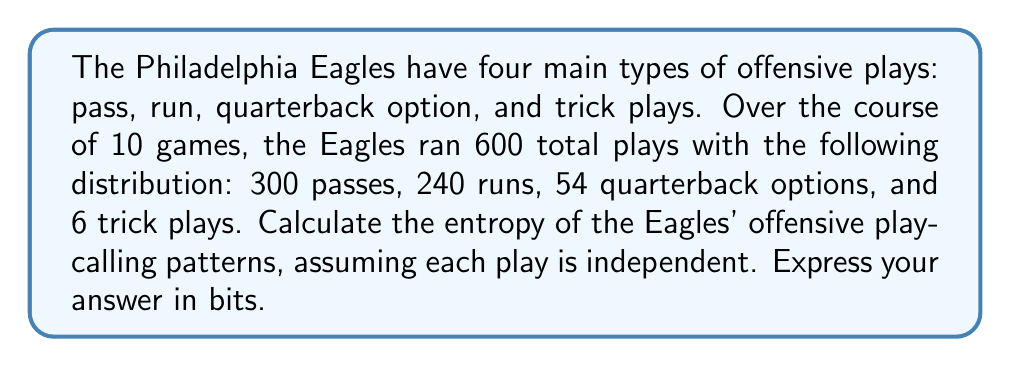Can you answer this question? To calculate the entropy of the Eagles' offensive play-calling patterns, we'll use the Shannon entropy formula:

$$S = -\sum_{i} p_i \log_2(p_i)$$

Where $p_i$ is the probability of each type of play.

Step 1: Calculate the probabilities for each play type.
$p_{pass} = 300/600 = 0.5$
$p_{run} = 240/600 = 0.4$
$p_{qb option} = 54/600 = 0.09$
$p_{trick} = 6/600 = 0.01$

Step 2: Calculate each term in the sum.
$-p_{pass} \log_2(p_{pass}) = -0.5 \log_2(0.5) = 0.5$
$-p_{run} \log_2(p_{run}) = -0.4 \log_2(0.4) \approx 0.5288$
$-p_{qb option} \log_2(p_{qb option}) = -0.09 \log_2(0.09) \approx 0.3133$
$-p_{trick} \log_2(p_{trick}) = -0.01 \log_2(0.01) \approx 0.0664$

Step 3: Sum all terms to get the entropy.
$$S = 0.5 + 0.5288 + 0.3133 + 0.0664 = 1.4085 \text{ bits}$$
Answer: 1.4085 bits 